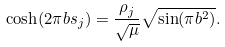Convert formula to latex. <formula><loc_0><loc_0><loc_500><loc_500>\cosh ( 2 \pi b s _ { j } ) = \frac { \rho _ { j } } { \sqrt { \mu } } \sqrt { \sin ( \pi b ^ { 2 } ) } .</formula> 